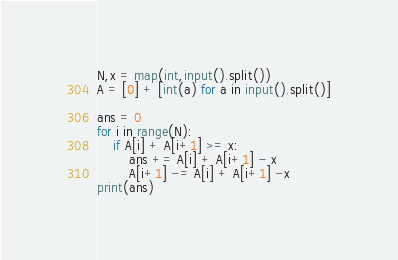Convert code to text. <code><loc_0><loc_0><loc_500><loc_500><_Python_>N,x = map(int,input().split())
A = [0] + [int(a) for a in input().split()]

ans = 0
for i in range(N):  
    if A[i] + A[i+1] >= x:
        ans += A[i] + A[i+1] - x
        A[i+1] -= A[i] + A[i+1] -x
print(ans)
</code> 